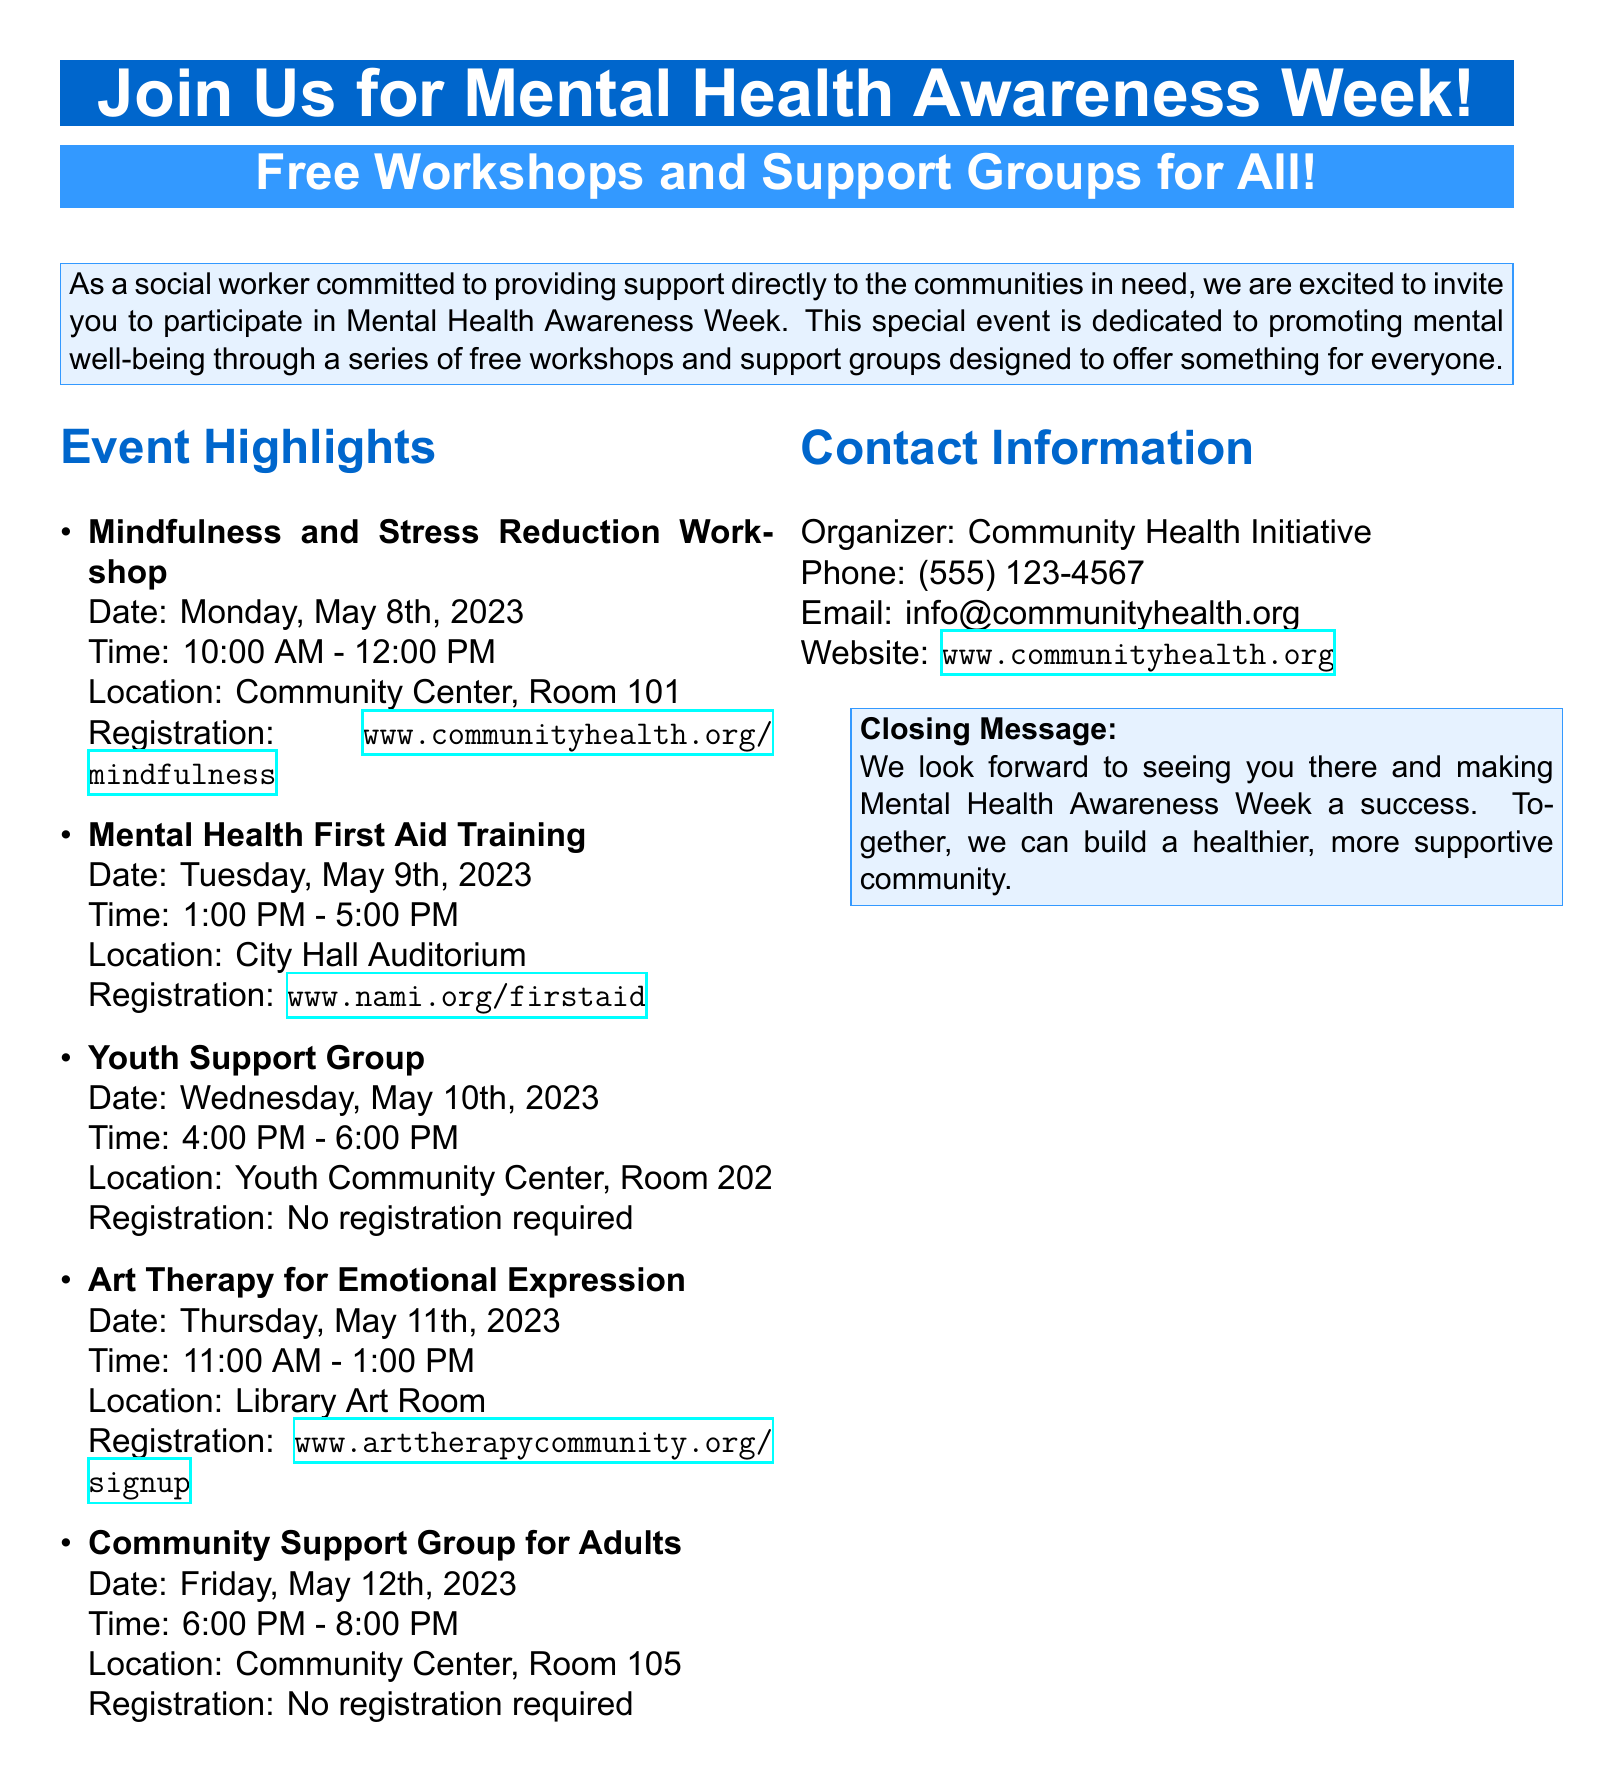What is the title of the event? The title of the event is prominently displayed at the top of the document.
Answer: Join Us for Mental Health Awareness Week! What type of training is offered on May 9th? The document lists specific workshops and support groups, highlighting the training available.
Answer: Mental Health First Aid Training When does the Youth Support Group take place? The date and time for the Youth Support Group are specified in the event highlights.
Answer: Wednesday, May 10th, 2023, 4:00 PM - 6:00 PM Where is the Art Therapy workshop held? The location for each workshop is provided in the document, specifically for the Art Therapy session.
Answer: Library Art Room How many workshops require registration? The number of workshops and their registration requirements are indicated in the document.
Answer: Three workshops require registration What is the phone number for the Community Health Initiative? Contact information, including a phone number, is provided in the document.
Answer: (555) 123-4567 Which day features a Community Support Group for Adults? The specific day for the Community Support Group is listed among the events.
Answer: Friday, May 12th, 2023 What is the main objective of the event? The objective is summarized in the introduction of the document.
Answer: Promoting mental well-being How can participants register for the Mindfulness and Stress Reduction Workshop? The registration link for specific workshops is explicitly mentioned in the document.
Answer: www.communityhealth.org/mindfulness 